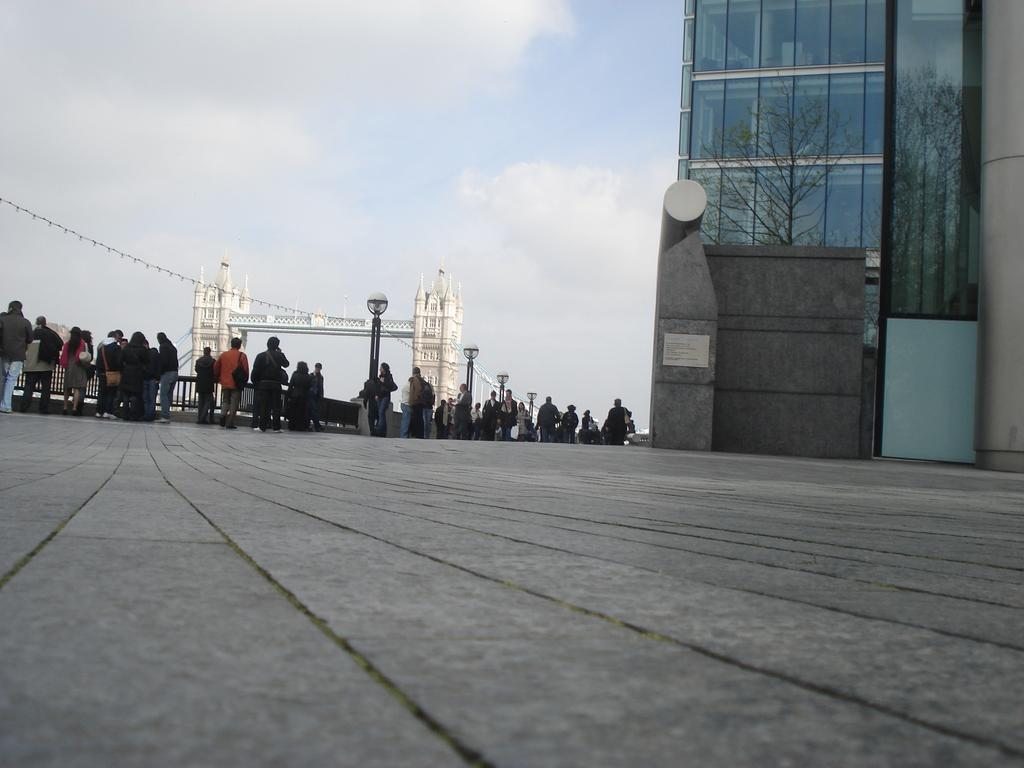What type of structure is present in the image? There is a building in the image. What are the people in the image doing? The people in the image are walking. What is the source of light visible in the image? A street lamp is visible in the image. What can be seen in the sky in the image? The sky is visible in the image. What is the reflection of in the building? There is a tree reflection on the building. What type of cart is being used for art and trade in the image? There is no cart present in the image, nor is there any indication of art or trade being conducted. 